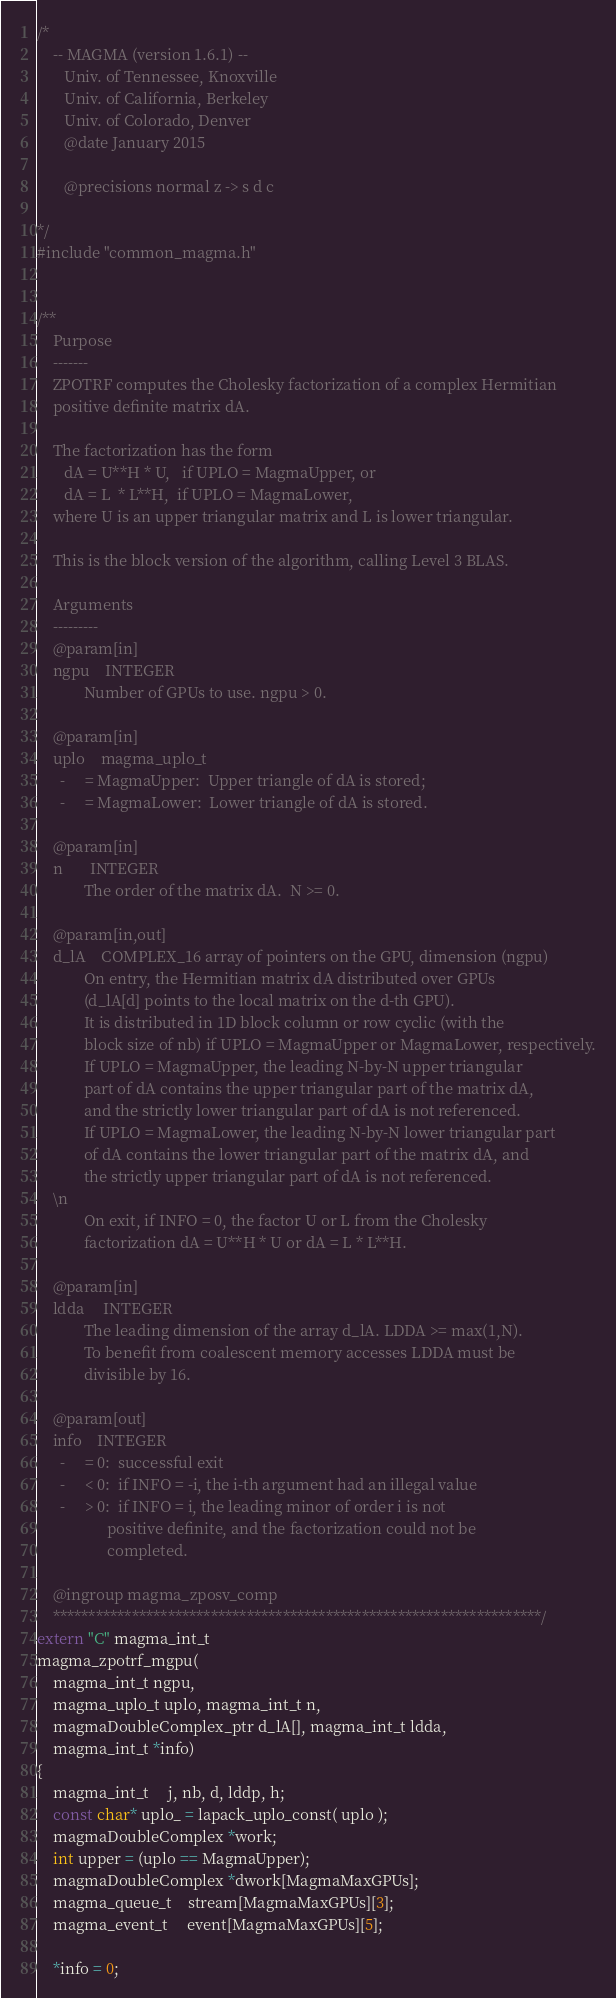Convert code to text. <code><loc_0><loc_0><loc_500><loc_500><_C++_>/*
    -- MAGMA (version 1.6.1) --
       Univ. of Tennessee, Knoxville
       Univ. of California, Berkeley
       Univ. of Colorado, Denver
       @date January 2015

       @precisions normal z -> s d c

*/
#include "common_magma.h"


/**
    Purpose
    -------
    ZPOTRF computes the Cholesky factorization of a complex Hermitian
    positive definite matrix dA.

    The factorization has the form
       dA = U**H * U,   if UPLO = MagmaUpper, or
       dA = L  * L**H,  if UPLO = MagmaLower,
    where U is an upper triangular matrix and L is lower triangular.

    This is the block version of the algorithm, calling Level 3 BLAS.

    Arguments
    ---------
    @param[in]
    ngpu    INTEGER
            Number of GPUs to use. ngpu > 0.

    @param[in]
    uplo    magma_uplo_t
      -     = MagmaUpper:  Upper triangle of dA is stored;
      -     = MagmaLower:  Lower triangle of dA is stored.

    @param[in]
    n       INTEGER
            The order of the matrix dA.  N >= 0.

    @param[in,out]
    d_lA    COMPLEX_16 array of pointers on the GPU, dimension (ngpu)
            On entry, the Hermitian matrix dA distributed over GPUs
            (d_lA[d] points to the local matrix on the d-th GPU).
            It is distributed in 1D block column or row cyclic (with the
            block size of nb) if UPLO = MagmaUpper or MagmaLower, respectively.
            If UPLO = MagmaUpper, the leading N-by-N upper triangular
            part of dA contains the upper triangular part of the matrix dA,
            and the strictly lower triangular part of dA is not referenced.
            If UPLO = MagmaLower, the leading N-by-N lower triangular part
            of dA contains the lower triangular part of the matrix dA, and
            the strictly upper triangular part of dA is not referenced.
    \n
            On exit, if INFO = 0, the factor U or L from the Cholesky
            factorization dA = U**H * U or dA = L * L**H.

    @param[in]
    ldda     INTEGER
            The leading dimension of the array d_lA. LDDA >= max(1,N).
            To benefit from coalescent memory accesses LDDA must be
            divisible by 16.

    @param[out]
    info    INTEGER
      -     = 0:  successful exit
      -     < 0:  if INFO = -i, the i-th argument had an illegal value
      -     > 0:  if INFO = i, the leading minor of order i is not
                  positive definite, and the factorization could not be
                  completed.

    @ingroup magma_zposv_comp
    ********************************************************************/
extern "C" magma_int_t
magma_zpotrf_mgpu(
    magma_int_t ngpu,
    magma_uplo_t uplo, magma_int_t n,
    magmaDoubleComplex_ptr d_lA[], magma_int_t ldda,
    magma_int_t *info)
{
    magma_int_t     j, nb, d, lddp, h;
    const char* uplo_ = lapack_uplo_const( uplo );
    magmaDoubleComplex *work;
    int upper = (uplo == MagmaUpper);
    magmaDoubleComplex *dwork[MagmaMaxGPUs];
    magma_queue_t    stream[MagmaMaxGPUs][3];
    magma_event_t     event[MagmaMaxGPUs][5];

    *info = 0;</code> 